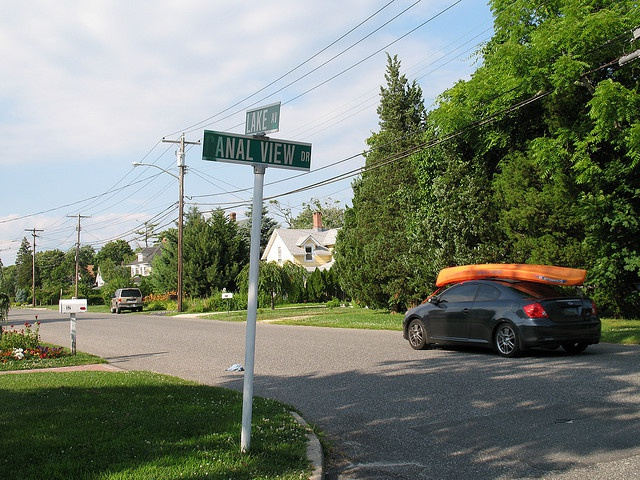Describe the objects in this image and their specific colors. I can see car in lightgray, black, gray, blue, and darkblue tones, boat in lightgray, red, orange, and gold tones, and car in lightgray, black, darkgray, gray, and tan tones in this image. 